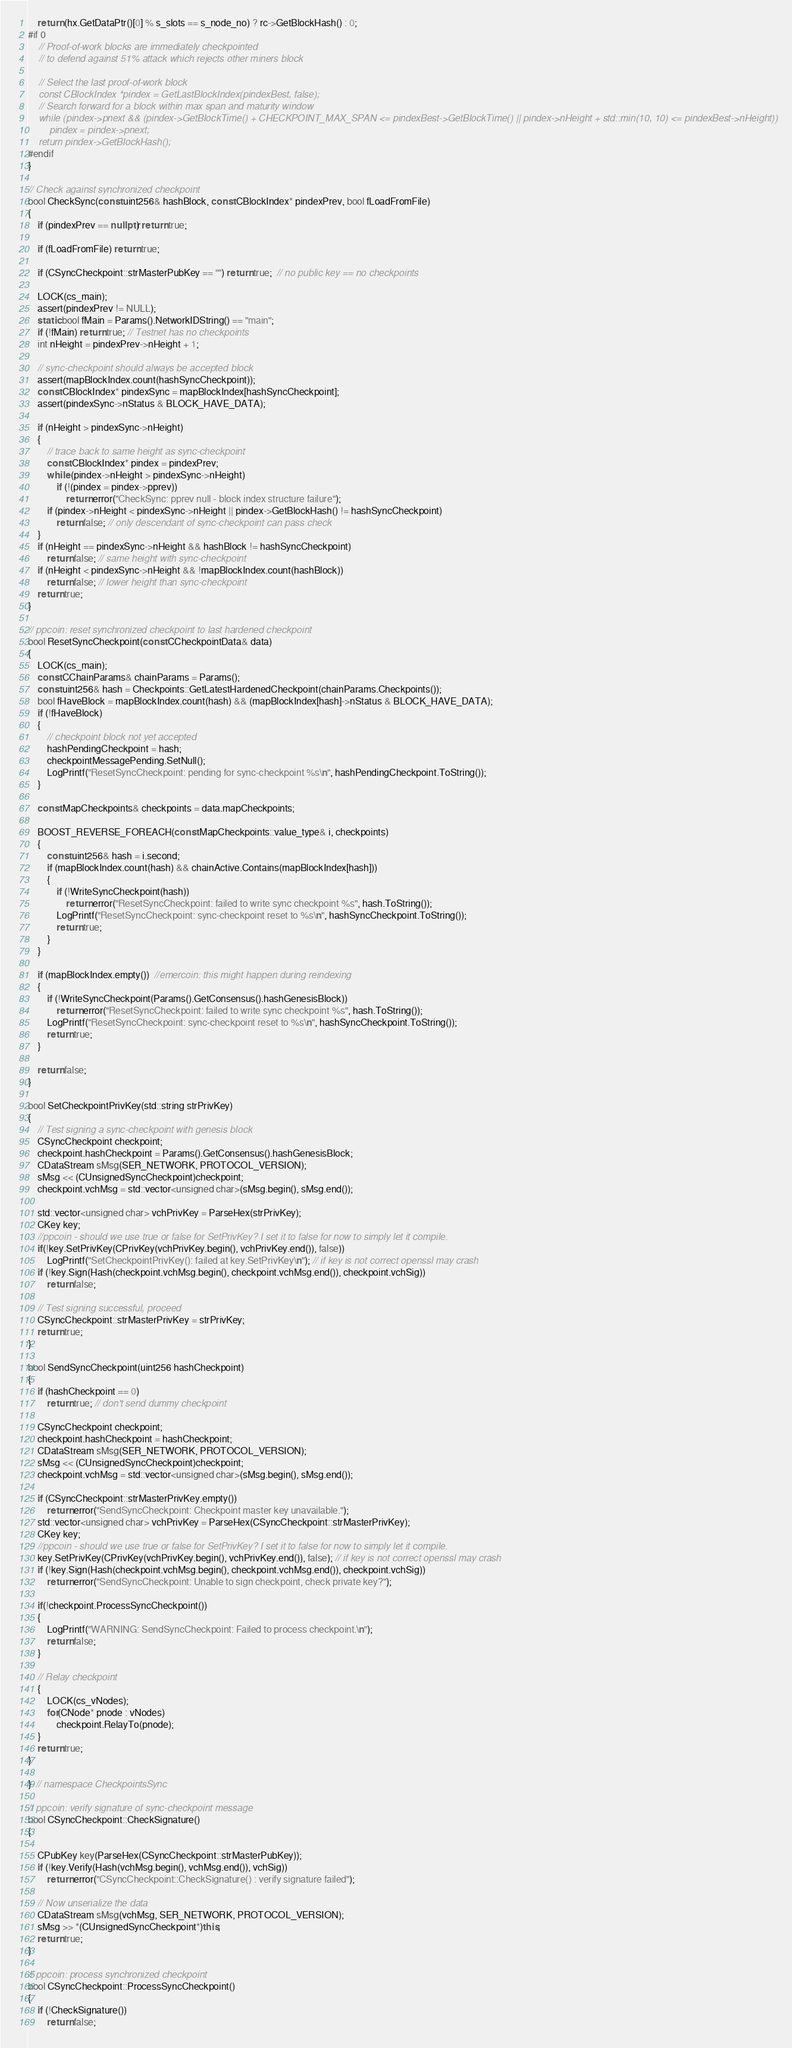Convert code to text. <code><loc_0><loc_0><loc_500><loc_500><_C++_>
    return (hx.GetDataPtr()[0] % s_slots == s_node_no) ? rc->GetBlockHash() : 0;
#if 0
    // Proof-of-work blocks are immediately checkpointed
    // to defend against 51% attack which rejects other miners block

    // Select the last proof-of-work block
    const CBlockIndex *pindex = GetLastBlockIndex(pindexBest, false);
    // Search forward for a block within max span and maturity window
    while (pindex->pnext && (pindex->GetBlockTime() + CHECKPOINT_MAX_SPAN <= pindexBest->GetBlockTime() || pindex->nHeight + std::min(10, 10) <= pindexBest->nHeight))
        pindex = pindex->pnext;
    return pindex->GetBlockHash();
#endif
}

// Check against synchronized checkpoint
bool CheckSync(const uint256& hashBlock, const CBlockIndex* pindexPrev, bool fLoadFromFile)
{
    if (pindexPrev == nullptr) return true;

    if (fLoadFromFile) return true;

    if (CSyncCheckpoint::strMasterPubKey == "") return true;  // no public key == no checkpoints

    LOCK(cs_main);
    assert(pindexPrev != NULL);
    static bool fMain = Params().NetworkIDString() == "main";
    if (!fMain) return true; // Testnet has no checkpoints
    int nHeight = pindexPrev->nHeight + 1;

    // sync-checkpoint should always be accepted block
    assert(mapBlockIndex.count(hashSyncCheckpoint));
    const CBlockIndex* pindexSync = mapBlockIndex[hashSyncCheckpoint];
    assert(pindexSync->nStatus & BLOCK_HAVE_DATA);

    if (nHeight > pindexSync->nHeight)
    {
        // trace back to same height as sync-checkpoint
        const CBlockIndex* pindex = pindexPrev;
        while (pindex->nHeight > pindexSync->nHeight)
            if (!(pindex = pindex->pprev))
                return error("CheckSync: pprev null - block index structure failure");
        if (pindex->nHeight < pindexSync->nHeight || pindex->GetBlockHash() != hashSyncCheckpoint)
            return false; // only descendant of sync-checkpoint can pass check
    }
    if (nHeight == pindexSync->nHeight && hashBlock != hashSyncCheckpoint)
        return false; // same height with sync-checkpoint
    if (nHeight < pindexSync->nHeight && !mapBlockIndex.count(hashBlock))
        return false; // lower height than sync-checkpoint
    return true;
}

// ppcoin: reset synchronized checkpoint to last hardened checkpoint
bool ResetSyncCheckpoint(const CCheckpointData& data)
{
    LOCK(cs_main);
    const CChainParams& chainParams = Params();
    const uint256& hash = Checkpoints::GetLatestHardenedCheckpoint(chainParams.Checkpoints());
    bool fHaveBlock = mapBlockIndex.count(hash) && (mapBlockIndex[hash]->nStatus & BLOCK_HAVE_DATA);
    if (!fHaveBlock)
    {
        // checkpoint block not yet accepted
        hashPendingCheckpoint = hash;
        checkpointMessagePending.SetNull();
        LogPrintf("ResetSyncCheckpoint: pending for sync-checkpoint %s\n", hashPendingCheckpoint.ToString());
    }

    const MapCheckpoints& checkpoints = data.mapCheckpoints;

    BOOST_REVERSE_FOREACH(const MapCheckpoints::value_type& i, checkpoints)
    {
        const uint256& hash = i.second;
        if (mapBlockIndex.count(hash) && chainActive.Contains(mapBlockIndex[hash]))
        {
            if (!WriteSyncCheckpoint(hash))
                return error("ResetSyncCheckpoint: failed to write sync checkpoint %s", hash.ToString());
            LogPrintf("ResetSyncCheckpoint: sync-checkpoint reset to %s\n", hashSyncCheckpoint.ToString());
            return true;
        }
    }

    if (mapBlockIndex.empty())  //emercoin: this might happen during reindexing
    {
        if (!WriteSyncCheckpoint(Params().GetConsensus().hashGenesisBlock))
            return error("ResetSyncCheckpoint: failed to write sync checkpoint %s", hash.ToString());
        LogPrintf("ResetSyncCheckpoint: sync-checkpoint reset to %s\n", hashSyncCheckpoint.ToString());
        return true;
    }

    return false;
}

bool SetCheckpointPrivKey(std::string strPrivKey)
{
    // Test signing a sync-checkpoint with genesis block
    CSyncCheckpoint checkpoint;
    checkpoint.hashCheckpoint = Params().GetConsensus().hashGenesisBlock;
    CDataStream sMsg(SER_NETWORK, PROTOCOL_VERSION);
    sMsg << (CUnsignedSyncCheckpoint)checkpoint;
    checkpoint.vchMsg = std::vector<unsigned char>(sMsg.begin(), sMsg.end());

    std::vector<unsigned char> vchPrivKey = ParseHex(strPrivKey);
    CKey key;
    //ppcoin - should we use true or false for SetPrivKey? I set it to false for now to simply let it compile.
    if(!key.SetPrivKey(CPrivKey(vchPrivKey.begin(), vchPrivKey.end()), false))
        LogPrintf("SetCheckpointPrivKey(): failed at key.SetPrivKey\n"); // if key is not correct openssl may crash
    if (!key.Sign(Hash(checkpoint.vchMsg.begin(), checkpoint.vchMsg.end()), checkpoint.vchSig))
        return false;

    // Test signing successful, proceed
    CSyncCheckpoint::strMasterPrivKey = strPrivKey;
    return true;
}

bool SendSyncCheckpoint(uint256 hashCheckpoint)
{
    if (hashCheckpoint == 0)
        return true; // don't send dummy checkpoint

    CSyncCheckpoint checkpoint;
    checkpoint.hashCheckpoint = hashCheckpoint;
    CDataStream sMsg(SER_NETWORK, PROTOCOL_VERSION);
    sMsg << (CUnsignedSyncCheckpoint)checkpoint;
    checkpoint.vchMsg = std::vector<unsigned char>(sMsg.begin(), sMsg.end());

    if (CSyncCheckpoint::strMasterPrivKey.empty())
        return error("SendSyncCheckpoint: Checkpoint master key unavailable.");
    std::vector<unsigned char> vchPrivKey = ParseHex(CSyncCheckpoint::strMasterPrivKey);
    CKey key;
    //ppcoin - should we use true or false for SetPrivKey? I set it to false for now to simply let it compile.
    key.SetPrivKey(CPrivKey(vchPrivKey.begin(), vchPrivKey.end()), false); // if key is not correct openssl may crash
    if (!key.Sign(Hash(checkpoint.vchMsg.begin(), checkpoint.vchMsg.end()), checkpoint.vchSig))
        return error("SendSyncCheckpoint: Unable to sign checkpoint, check private key?");

    if(!checkpoint.ProcessSyncCheckpoint())
    {
        LogPrintf("WARNING: SendSyncCheckpoint: Failed to process checkpoint.\n");
        return false;
    }

    // Relay checkpoint
    {
        LOCK(cs_vNodes);
        for(CNode* pnode : vNodes)
            checkpoint.RelayTo(pnode);
    }
    return true;
}

}  // namespace CheckpointsSync

// ppcoin: verify signature of sync-checkpoint message
bool CSyncCheckpoint::CheckSignature()
{

    CPubKey key(ParseHex(CSyncCheckpoint::strMasterPubKey));
    if (!key.Verify(Hash(vchMsg.begin(), vchMsg.end()), vchSig))
        return error("CSyncCheckpoint::CheckSignature() : verify signature failed");

    // Now unserialize the data
    CDataStream sMsg(vchMsg, SER_NETWORK, PROTOCOL_VERSION);
    sMsg >> *(CUnsignedSyncCheckpoint*)this;
    return true;
}

// ppcoin: process synchronized checkpoint
bool CSyncCheckpoint::ProcessSyncCheckpoint()
{
    if (!CheckSignature())
        return false;
</code> 